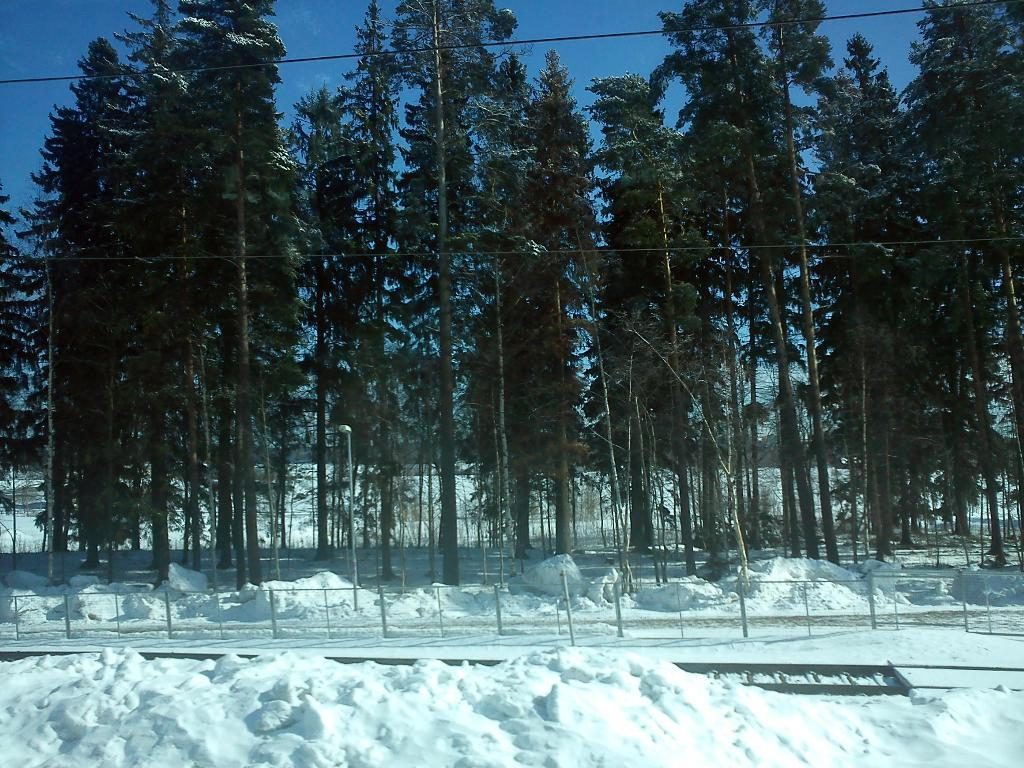What type of vegetation can be seen in the image? There are trees in the image. What else is present in the image besides trees? There are wires and poles in the image. What is the weather like in the image? There is snow visible in the image, indicating a cold or wintery environment. What material is the metal object made of? The metal object in the image is made of metal. What can be seen in the background of the image? The sky is visible in the background of the image. Can you tell me how many monkeys are sitting on the metal object in the image? There are no monkeys present in the image; it features trees, wires, poles, snow, and a metal object. What type of steam is coming out of the trees in the image? There is no steam present in the image; it features trees, wires, poles, snow, and a metal object. 